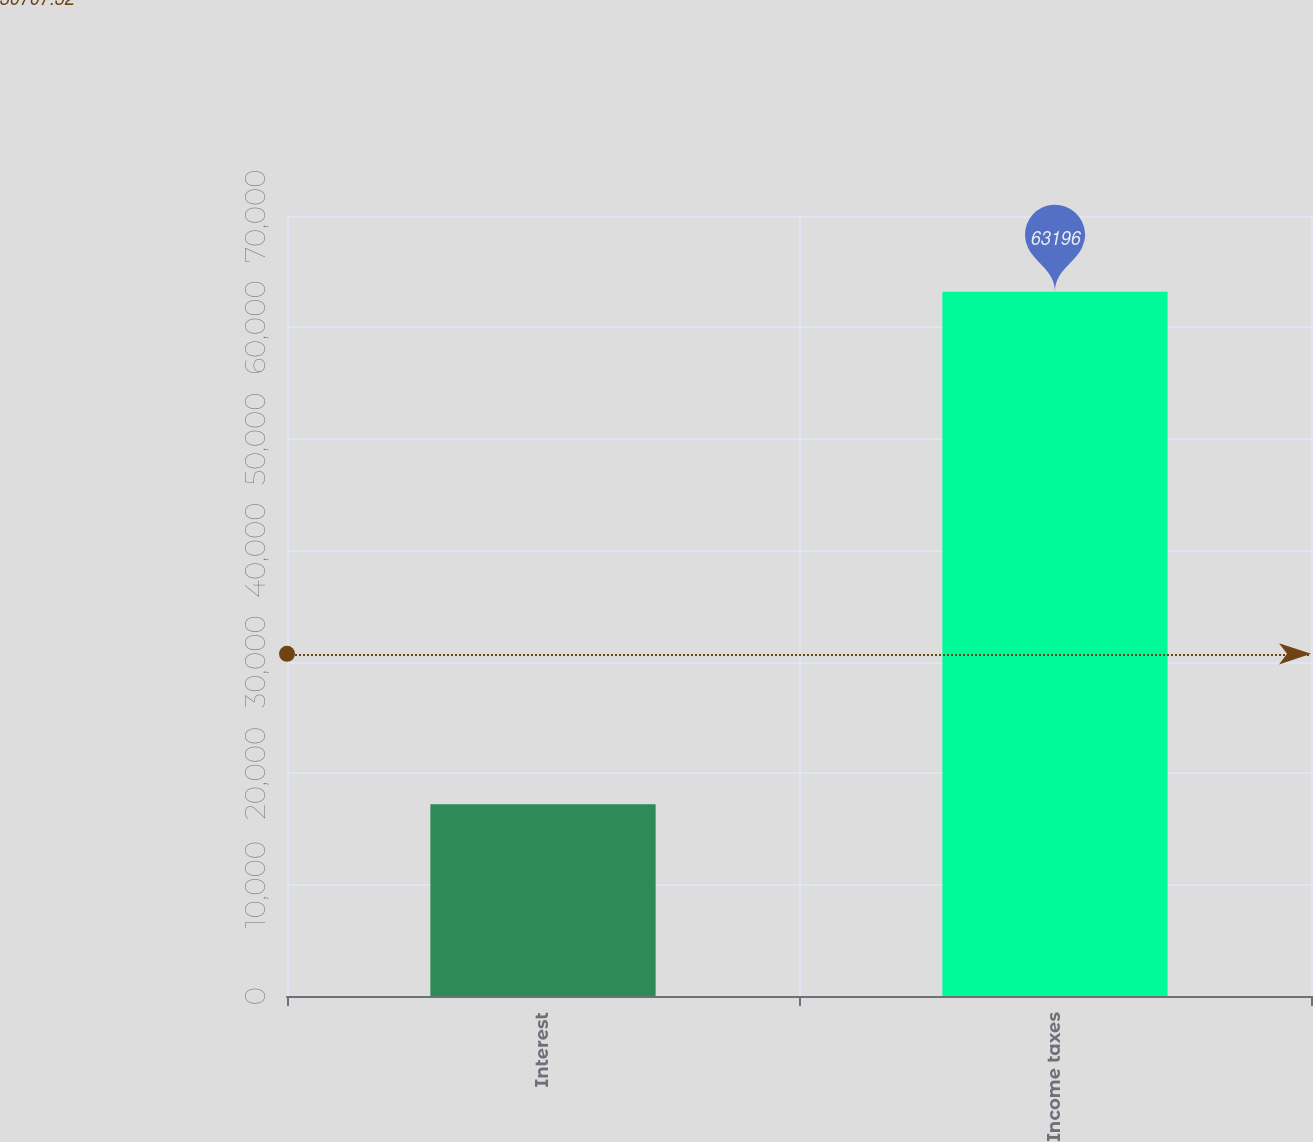<chart> <loc_0><loc_0><loc_500><loc_500><bar_chart><fcel>Interest<fcel>Income taxes<nl><fcel>17217<fcel>63196<nl></chart> 